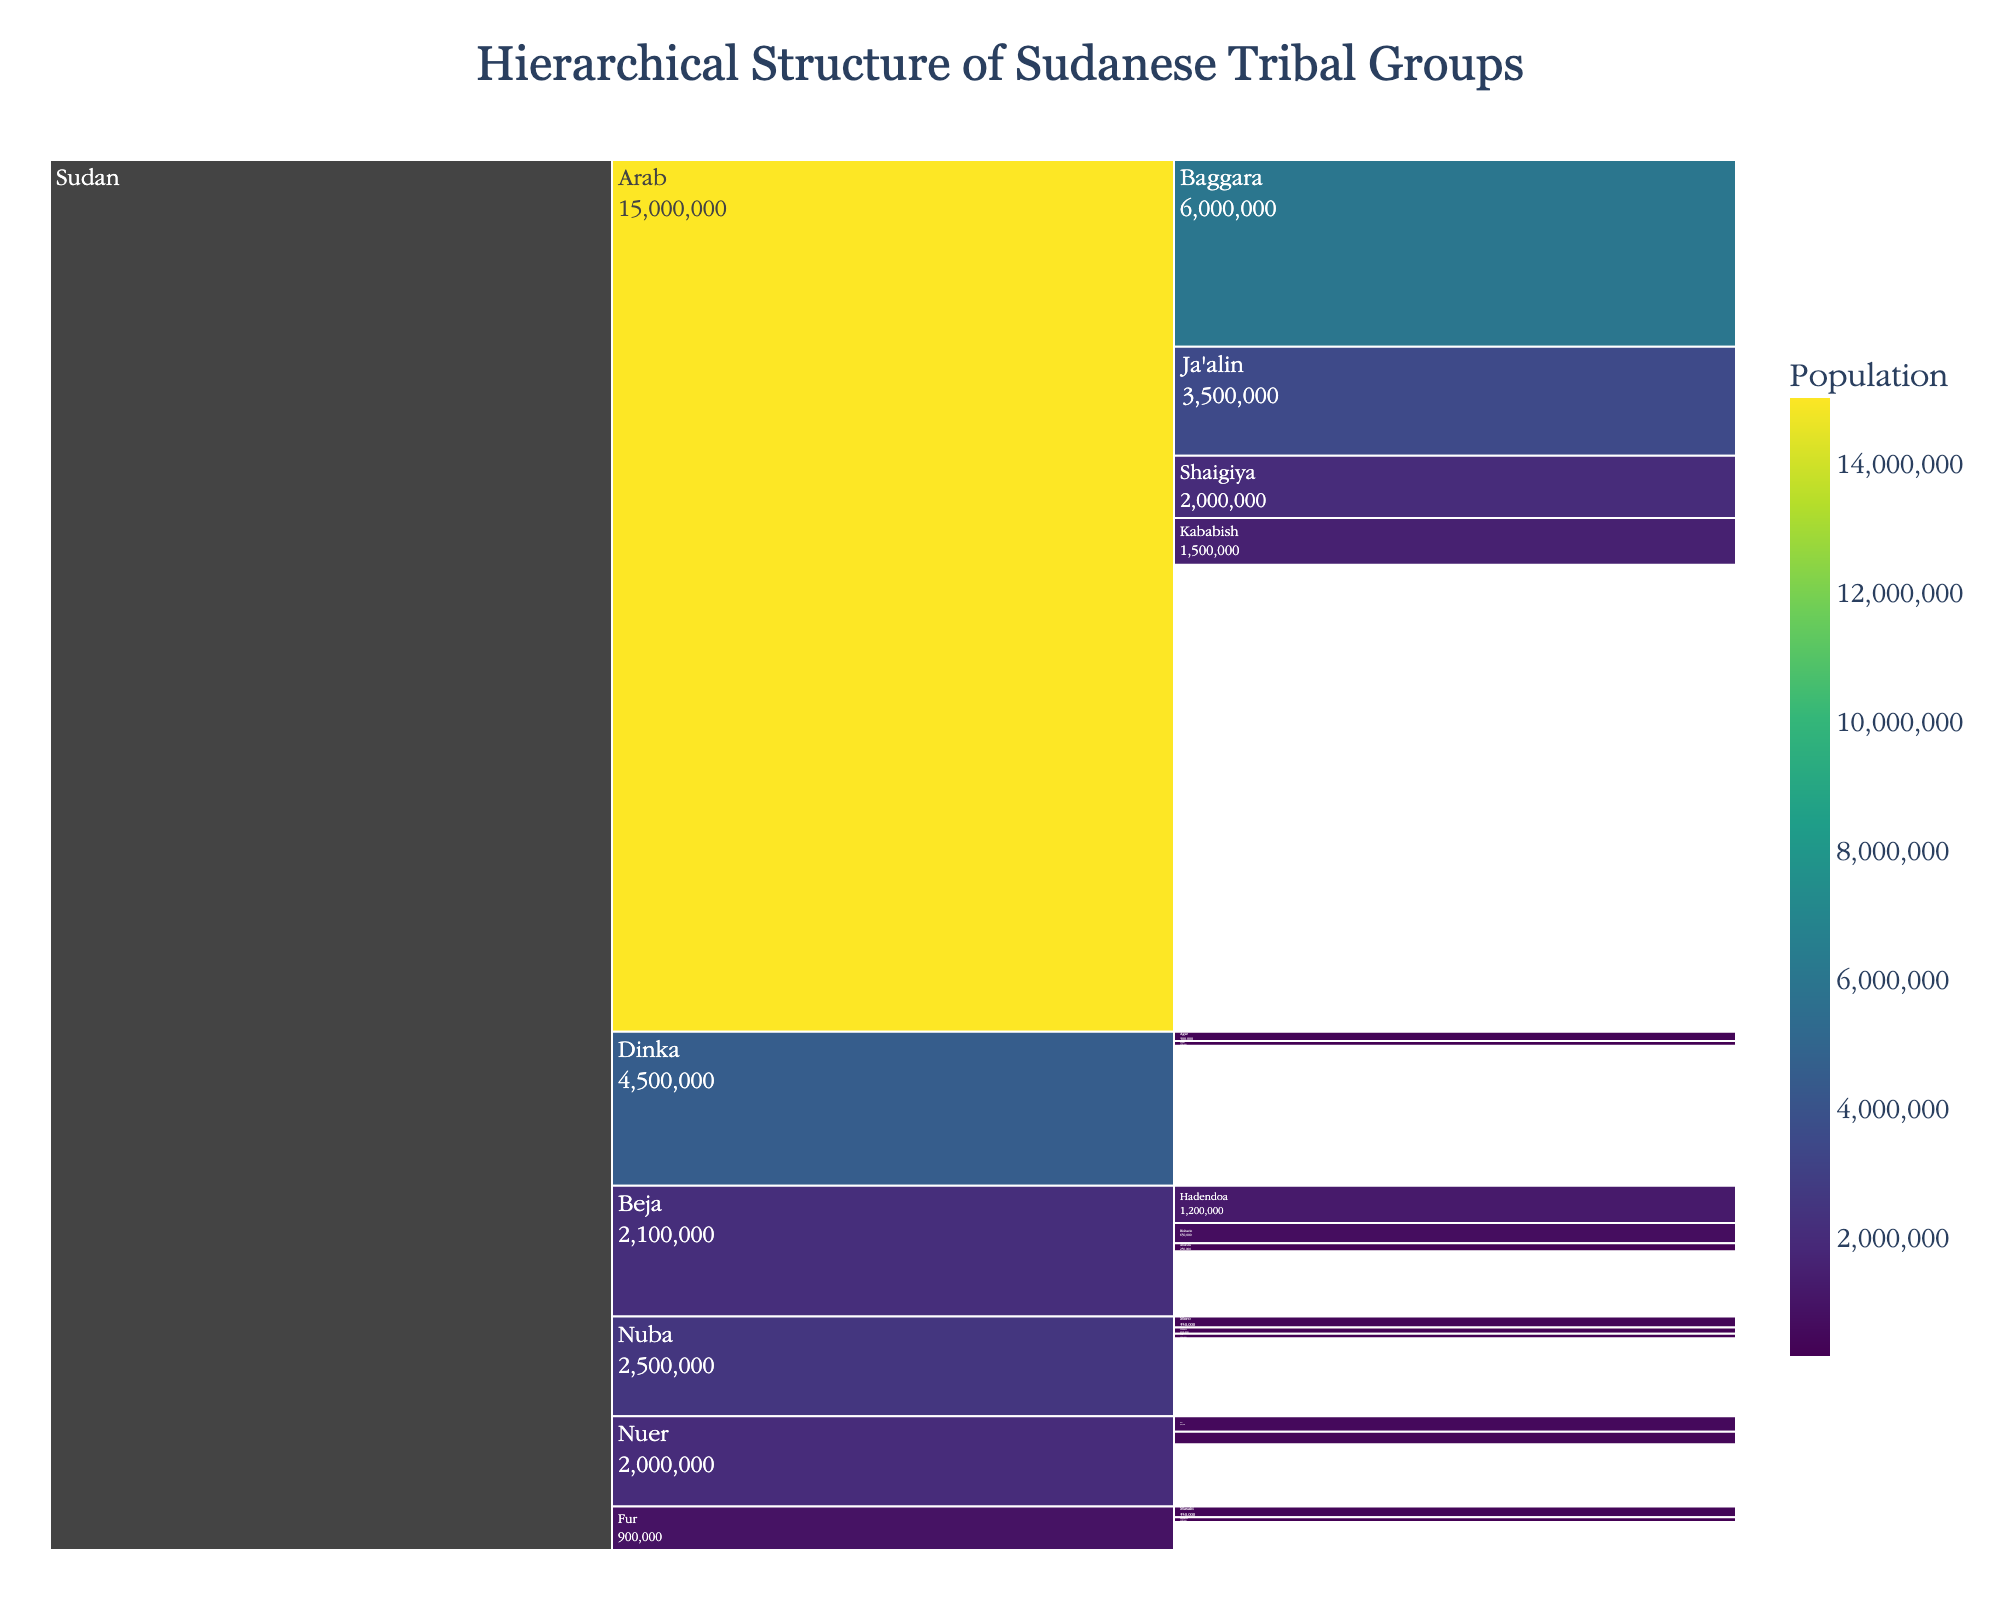What's the largest tribal group in Sudan based on population? The icicle chart shows various tribal groups and their populations. The largest value appears under the "Arab" group with a population of 15,000,000.
Answer: Arab Which tribal group within the Beja has the smallest population? Within the Beja group, there are three sub-groups: Ababda, Hadendoa, and Bisharin. Comparing the populations, Bisharin has 650,000, Hadendoa has 1,200,000, and Ababda has 250,000. Therefore, Ababda has the smallest population.
Answer: Ababda What's the combined population of the Nuba and Fur groups? The Nuba group has a population of 2,500,000, and the Fur group has 900,000. Summing these gives 2,500,000 + 900,000 = 3,400,000.
Answer: 3,400,000 Which group is larger: Dinka or Nuer? Comparing the populations, the Dinka group has 4,500,000 and the Nuer group has 2,000,000. Hence, the Dinka group is larger.
Answer: Dinka Is the population of the Ja'alin group greater than that of the Shaigiya group? The Ja'alin group has a population of 3,500,000, and the Shaigiya group has 2,000,000. Therefore, the Ja'alin population is greater.
Answer: Yes What's the aggregate population of all the sub-groups under the Beja group? Adding the populations of the sub-groups under the Beja group: Ababda (250,000) + Hadendoa (1,200,000) + Bisharin (650,000). This sums to 250,000 + 1,200,000 + 650,000 = 2,100,000.
Answer: 2,100,000 Which group has the lowest population under the Nuba? There are three sub-groups under the Nuba: Moro (350,000), Otoro (200,000), and Tira (150,000). Out of these, Tira has the lowest population.
Answer: Tira What's the ratio of the population of Baggara to Kababish in the Arab group? The population of Baggara is 6,000,000, and the population of Kababish is 1,500,000. The ratio is 6,000,000 / 1,500,000 = 4.
Answer: 4 What's the total population under Sudan excluding the Arab group? The total population excluding the Arab group is a sum of populations of Beja (2,100,000), Nuba (2,500,000), Fur (900,000), Dinka (4,500,000), and Nuer (2,000,000). Totaling these gives 2,100,000 + 2,500,000 + 900,000 + 4,500,000 + 2,000,000 = 12,000,000.
Answer: 12,000,000 From the chart, which tribal group has a more evenly distributed population among its sub-groups, Beja or Nuer? In the Beja group, the sub-groups are Ababda (250,000), Hadendoa (1,200,000), and Bisharin (650,000). In the Nuer group, the sub-groups are Lou (500,000) and Jikany (400,000). The populations in Nuer sub-groups are closer in size compared to the Beja sub-groups.
Answer: Nuer 